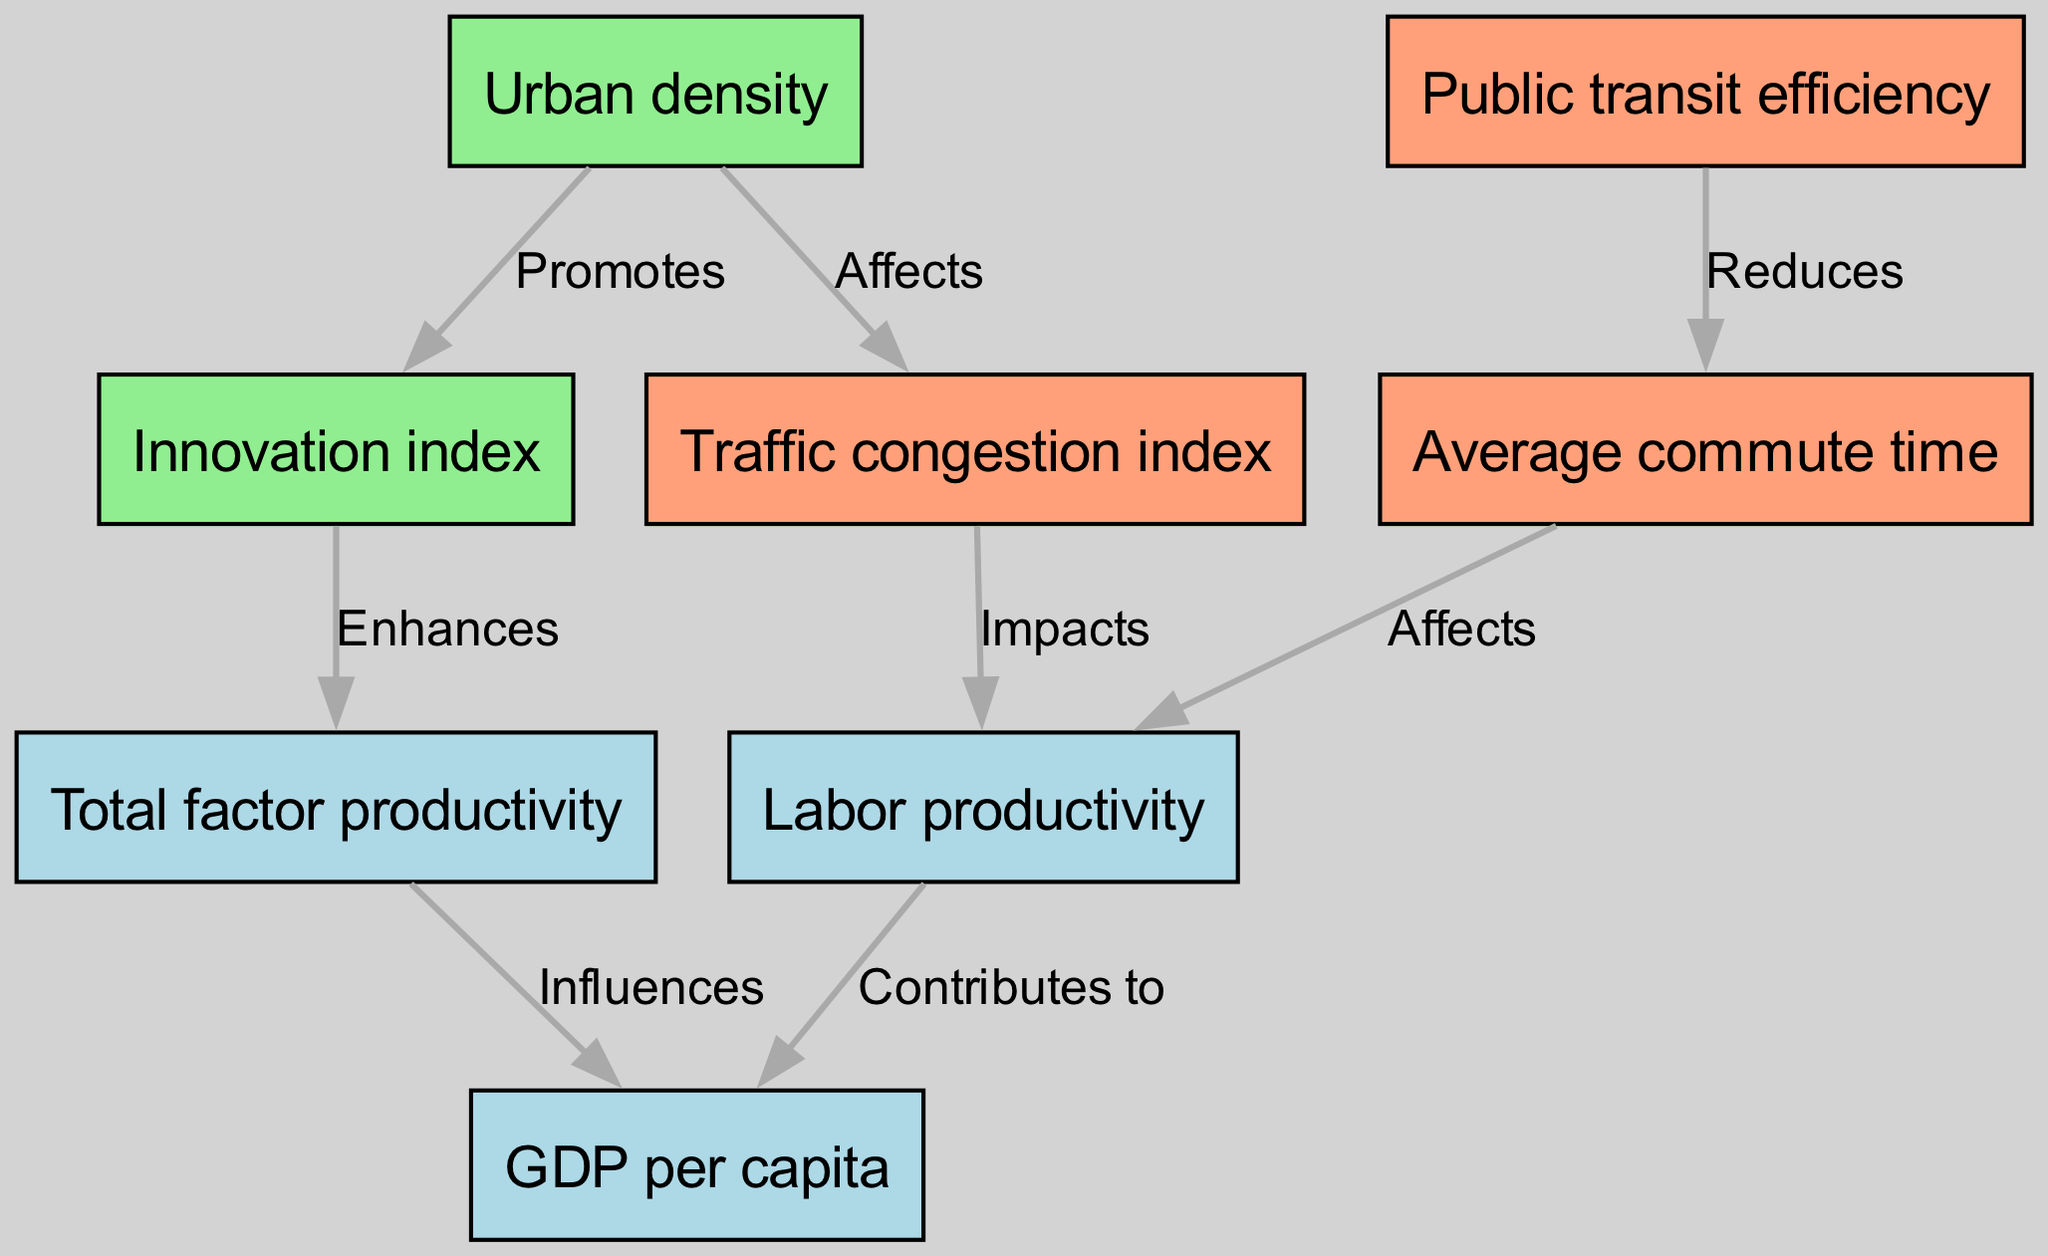What are the two main economic productivity metrics depicted in the diagram? The diagram shows GDP per capita and Labor productivity as the two main economic productivity metrics. They are clearly identified as nodes within the economic indicators section of the diagram.
Answer: GDP per capita, Labor productivity Which node is impacted by the traffic congestion index? According to the diagram, the Labor productivity is impacted by the Traffic congestion index, as indicated by the directed edge labeled "Impacts".
Answer: Labor productivity How many edges are in the diagram? By counting the connections between nodes, there are a total of eight edges in the diagram. Each edge represents a relationship between two different metrics.
Answer: Eight What relationship exists between urban density and the traffic congestion index? Urban density affects the traffic congestion index, as indicated by the directed edge between the Urban density node and the Traffic congestion index node, labeled "Affects".
Answer: Affects How does public transit efficiency influence average commute time? The diagram shows that public transit efficiency reduces average commute time, which indicates a negative correlation between these two nodes, represented by the directed edge labeled "Reduces".
Answer: Reduces What metrics contribute to maintaining economic productivity? Both Labor productivity and Total factor productivity contribute to GDP per capita, as shown by the directed edges leading to the GDP per capita node.
Answer: Labor productivity, Total factor productivity Which metric enhances total factor productivity? According to the diagram, the Innovation index enhances total factor productivity, which is represented by the directed edge that connects the two nodes with the label "Enhances".
Answer: Innovation index What promotes urban density? According to the diagram's structure, the Innovation index promotes urban density, as indicated by the directed edge labeled "Promotes".
Answer: Innovation index 